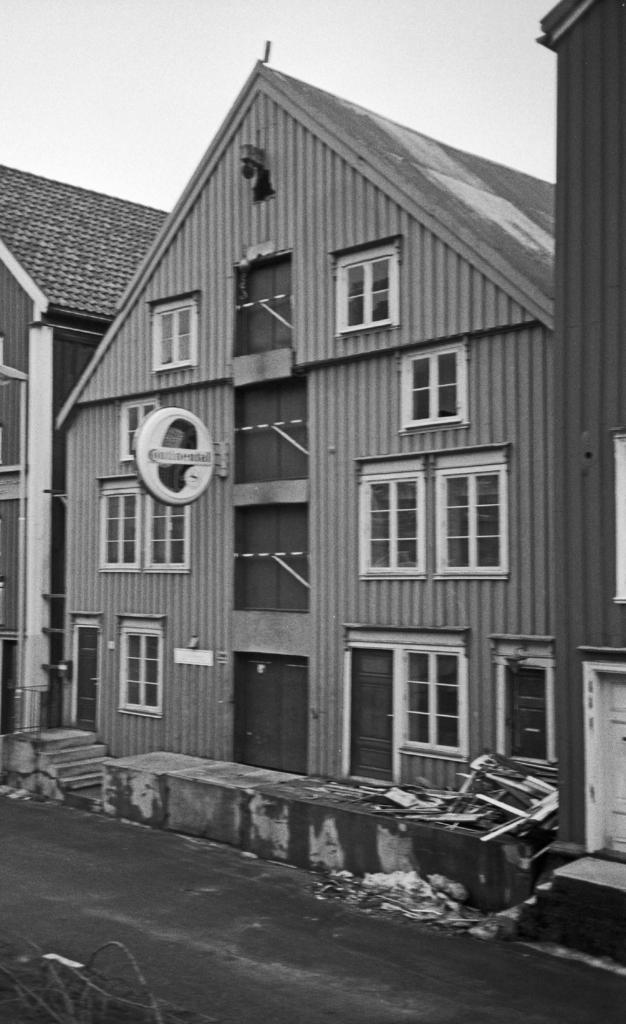What is the color scheme of the image? The image is black and white. What can be seen in the sky in the image? There is a sky visible in the image. What type of buildings are in the image? There are houses in the image. What architectural features are present in the houses? Windows and doors are visible in the image. What is located on top of the houses in the image? Rooftops are in the image. What is the primary mode of transportation visible in the image? There is a road in the image. What additional object is present in the image? A board is present in the image. What might be used for ascending or descending between levels in the image? Stairs are visible in the image. Can you describe any other objects present in the image? There are other objects in the image, but their specific details are not mentioned in the provided facts. How many lizards can be seen crawling on the board in the image? There are no lizards present in the image. What type of car is parked on the road in the image? There is no car visible in the image; only a road is mentioned. 